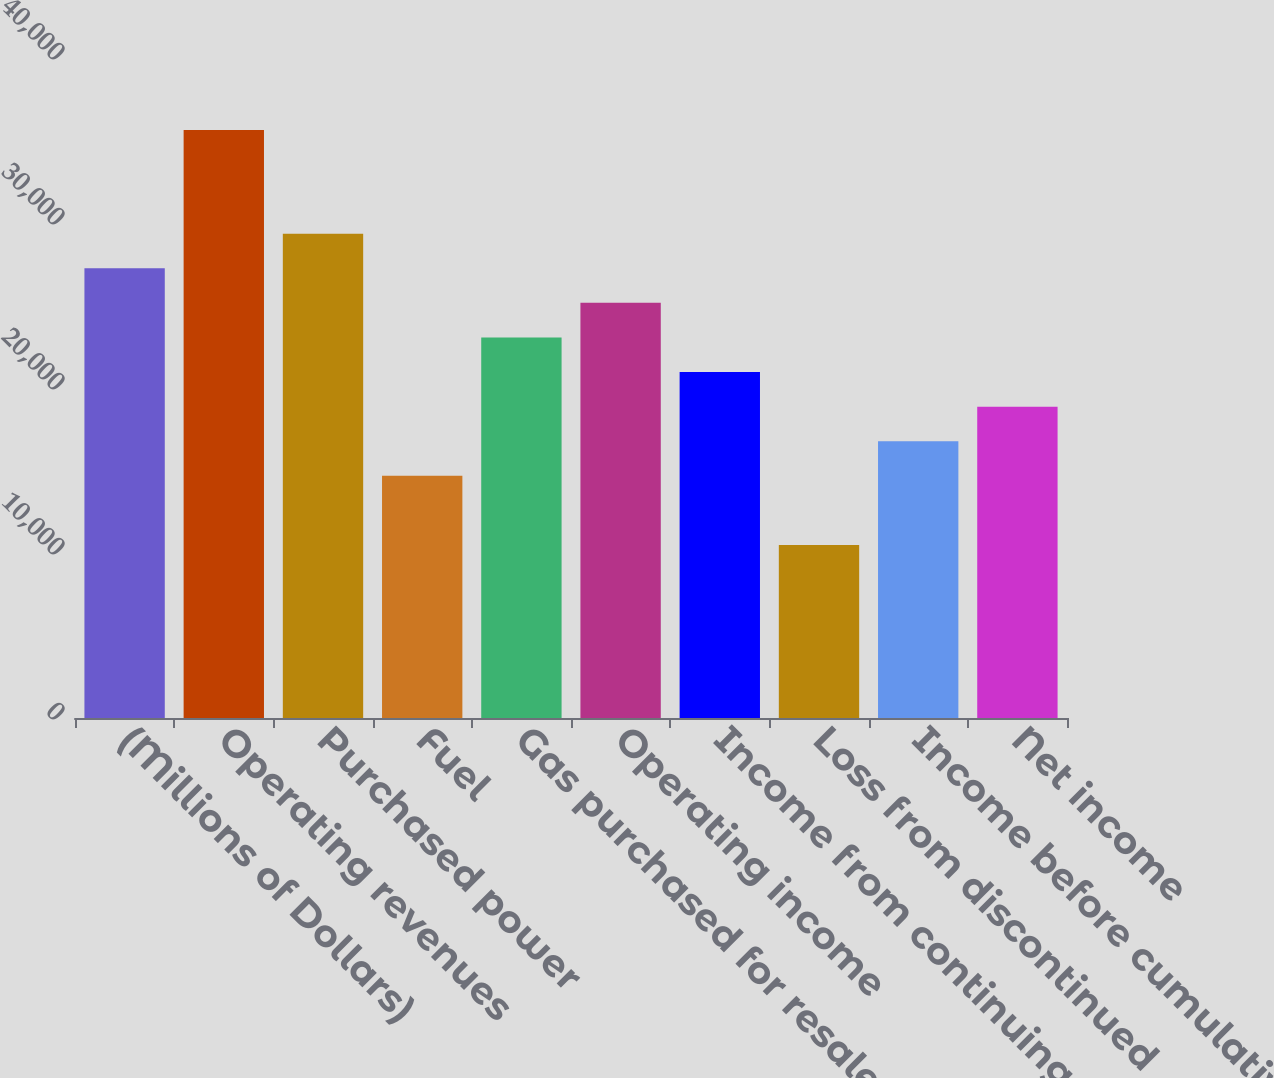<chart> <loc_0><loc_0><loc_500><loc_500><bar_chart><fcel>(Millions of Dollars)<fcel>Operating revenues<fcel>Purchased power<fcel>Fuel<fcel>Gas purchased for resale<fcel>Operating income<fcel>Income from continuing<fcel>Loss from discontinued<fcel>Income before cumulative<fcel>Net income<nl><fcel>27255.7<fcel>35641.8<fcel>29352.2<fcel>14676.4<fcel>23062.5<fcel>25159.1<fcel>20966<fcel>10483.2<fcel>16772.9<fcel>18869.5<nl></chart> 